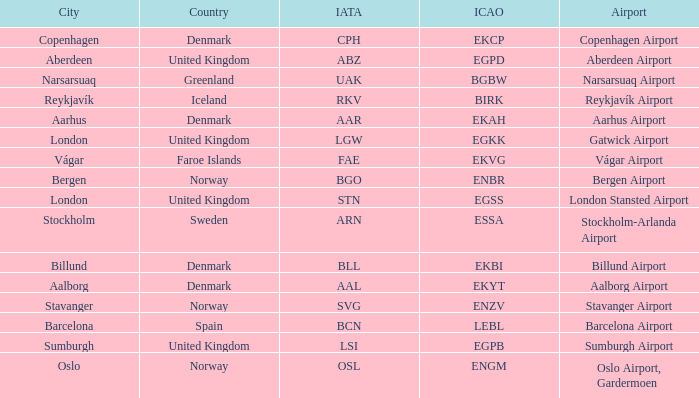What is the ICAO for Denmark, and the IATA is bll? EKBI. 